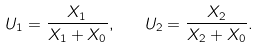Convert formula to latex. <formula><loc_0><loc_0><loc_500><loc_500>U _ { 1 } = \frac { X _ { 1 } } { X _ { 1 } + X _ { 0 } } , \quad U _ { 2 } = \frac { X _ { 2 } } { X _ { 2 } + X _ { 0 } } .</formula> 